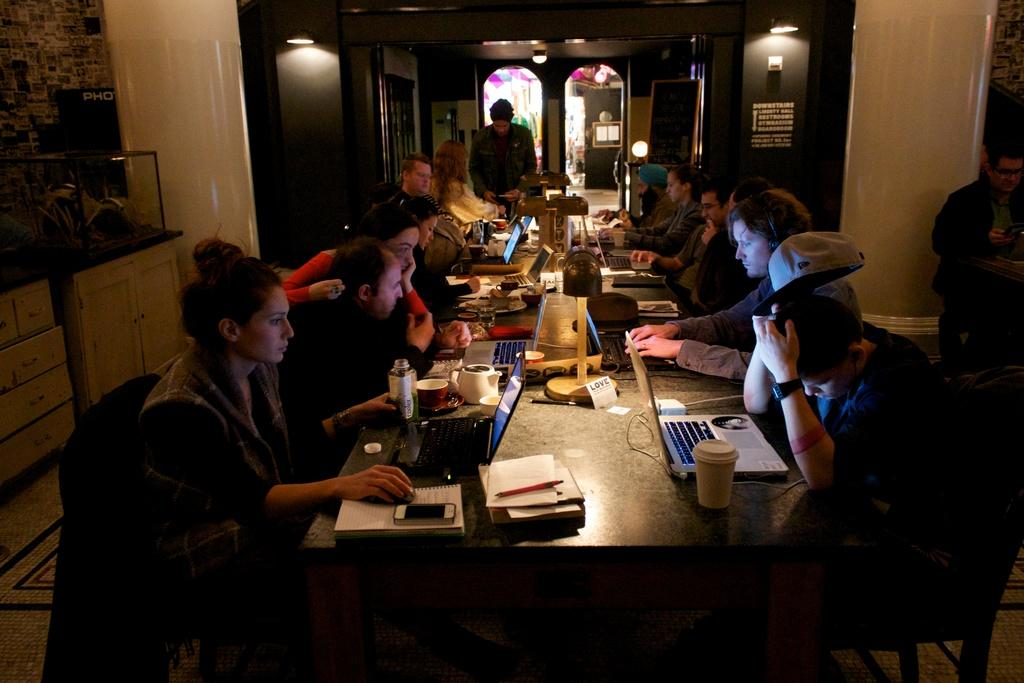What are the people in the image doing? The people in the image are sitting on chairs around a table. What objects can be seen on the table? There is a laptop, glasses, books, pens, and mobile phones on the table. What is the purpose of the chairs and table in the image? The chairs and table suggest that the people are gathered for a meeting or discussion. What is visible on the wall in the image? There is a wall visible in the image, but no specific details are provided about its contents. How many people are sleeping in the image? There are no people sleeping in the image; they are sitting on chairs around a table. What type of body is present in the image? There are no bodies present in the image, only people sitting on chairs. 